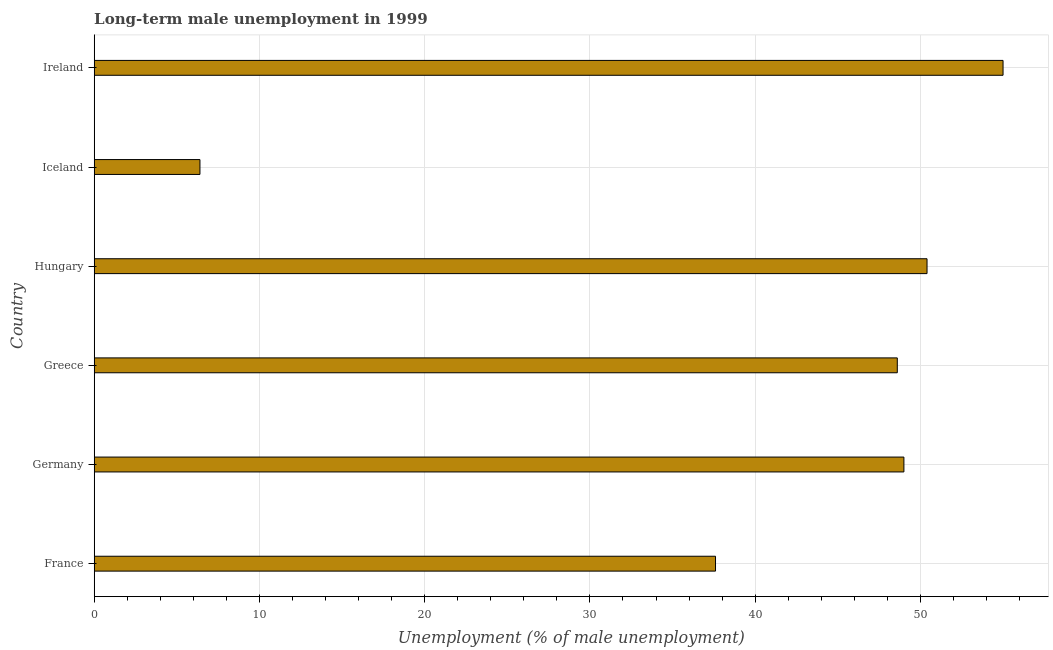What is the title of the graph?
Your answer should be compact. Long-term male unemployment in 1999. What is the label or title of the X-axis?
Make the answer very short. Unemployment (% of male unemployment). What is the long-term male unemployment in Germany?
Offer a terse response. 49. Across all countries, what is the maximum long-term male unemployment?
Your answer should be compact. 55. Across all countries, what is the minimum long-term male unemployment?
Offer a terse response. 6.4. In which country was the long-term male unemployment maximum?
Ensure brevity in your answer.  Ireland. What is the sum of the long-term male unemployment?
Offer a very short reply. 247. What is the difference between the long-term male unemployment in France and Ireland?
Your response must be concise. -17.4. What is the average long-term male unemployment per country?
Ensure brevity in your answer.  41.17. What is the median long-term male unemployment?
Your answer should be very brief. 48.8. What is the ratio of the long-term male unemployment in Iceland to that in Ireland?
Provide a succinct answer. 0.12. Is the long-term male unemployment in Hungary less than that in Iceland?
Offer a very short reply. No. Is the difference between the long-term male unemployment in Greece and Iceland greater than the difference between any two countries?
Make the answer very short. No. What is the difference between the highest and the second highest long-term male unemployment?
Give a very brief answer. 4.6. Is the sum of the long-term male unemployment in Hungary and Ireland greater than the maximum long-term male unemployment across all countries?
Provide a succinct answer. Yes. What is the difference between the highest and the lowest long-term male unemployment?
Your answer should be very brief. 48.6. Are all the bars in the graph horizontal?
Make the answer very short. Yes. What is the Unemployment (% of male unemployment) of France?
Your response must be concise. 37.6. What is the Unemployment (% of male unemployment) of Greece?
Your answer should be compact. 48.6. What is the Unemployment (% of male unemployment) of Hungary?
Provide a short and direct response. 50.4. What is the Unemployment (% of male unemployment) of Iceland?
Ensure brevity in your answer.  6.4. What is the Unemployment (% of male unemployment) in Ireland?
Provide a succinct answer. 55. What is the difference between the Unemployment (% of male unemployment) in France and Hungary?
Your response must be concise. -12.8. What is the difference between the Unemployment (% of male unemployment) in France and Iceland?
Offer a terse response. 31.2. What is the difference between the Unemployment (% of male unemployment) in France and Ireland?
Give a very brief answer. -17.4. What is the difference between the Unemployment (% of male unemployment) in Germany and Hungary?
Give a very brief answer. -1.4. What is the difference between the Unemployment (% of male unemployment) in Germany and Iceland?
Provide a succinct answer. 42.6. What is the difference between the Unemployment (% of male unemployment) in Germany and Ireland?
Offer a very short reply. -6. What is the difference between the Unemployment (% of male unemployment) in Greece and Hungary?
Keep it short and to the point. -1.8. What is the difference between the Unemployment (% of male unemployment) in Greece and Iceland?
Your response must be concise. 42.2. What is the difference between the Unemployment (% of male unemployment) in Hungary and Iceland?
Your response must be concise. 44. What is the difference between the Unemployment (% of male unemployment) in Hungary and Ireland?
Give a very brief answer. -4.6. What is the difference between the Unemployment (% of male unemployment) in Iceland and Ireland?
Your response must be concise. -48.6. What is the ratio of the Unemployment (% of male unemployment) in France to that in Germany?
Your answer should be compact. 0.77. What is the ratio of the Unemployment (% of male unemployment) in France to that in Greece?
Provide a short and direct response. 0.77. What is the ratio of the Unemployment (% of male unemployment) in France to that in Hungary?
Your response must be concise. 0.75. What is the ratio of the Unemployment (% of male unemployment) in France to that in Iceland?
Make the answer very short. 5.88. What is the ratio of the Unemployment (% of male unemployment) in France to that in Ireland?
Your answer should be compact. 0.68. What is the ratio of the Unemployment (% of male unemployment) in Germany to that in Iceland?
Provide a succinct answer. 7.66. What is the ratio of the Unemployment (% of male unemployment) in Germany to that in Ireland?
Provide a short and direct response. 0.89. What is the ratio of the Unemployment (% of male unemployment) in Greece to that in Hungary?
Offer a very short reply. 0.96. What is the ratio of the Unemployment (% of male unemployment) in Greece to that in Iceland?
Keep it short and to the point. 7.59. What is the ratio of the Unemployment (% of male unemployment) in Greece to that in Ireland?
Give a very brief answer. 0.88. What is the ratio of the Unemployment (% of male unemployment) in Hungary to that in Iceland?
Provide a succinct answer. 7.88. What is the ratio of the Unemployment (% of male unemployment) in Hungary to that in Ireland?
Your answer should be compact. 0.92. What is the ratio of the Unemployment (% of male unemployment) in Iceland to that in Ireland?
Provide a succinct answer. 0.12. 